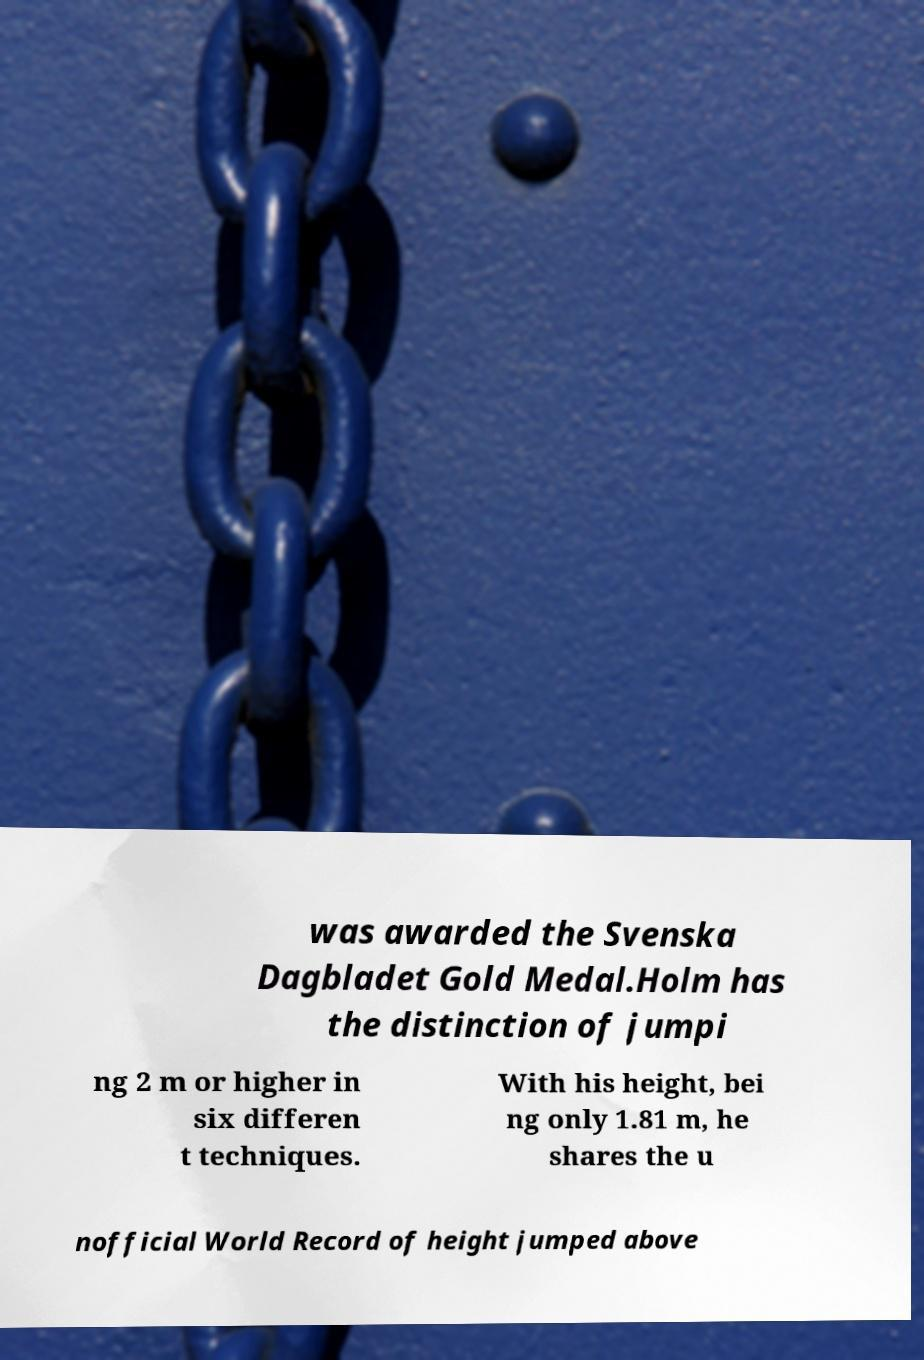I need the written content from this picture converted into text. Can you do that? was awarded the Svenska Dagbladet Gold Medal.Holm has the distinction of jumpi ng 2 m or higher in six differen t techniques. With his height, bei ng only 1.81 m, he shares the u nofficial World Record of height jumped above 